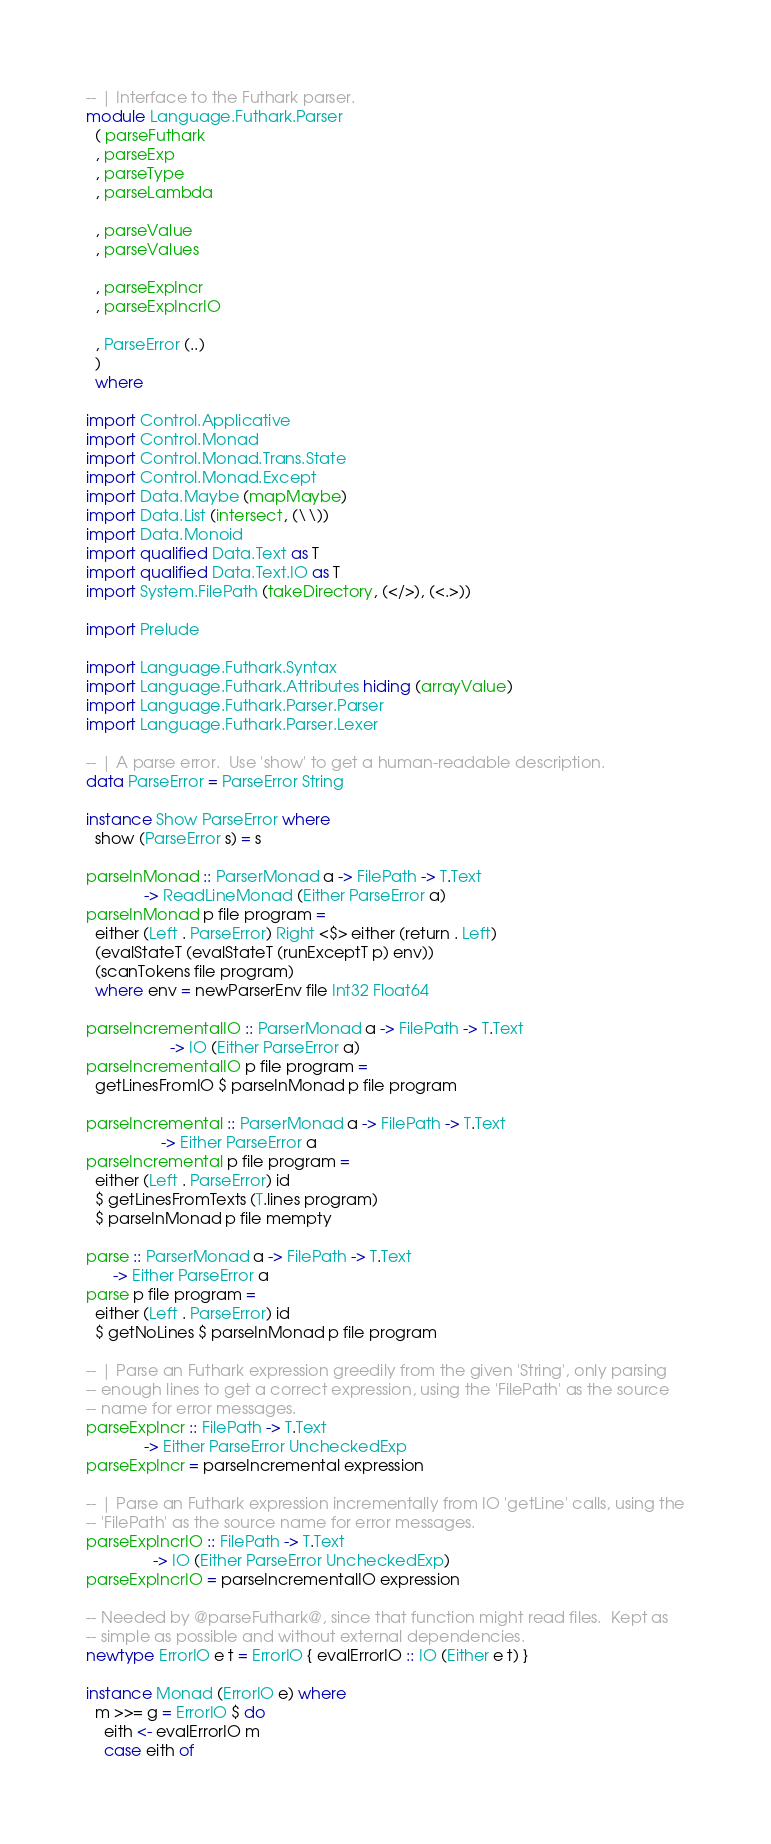Convert code to text. <code><loc_0><loc_0><loc_500><loc_500><_Haskell_>-- | Interface to the Futhark parser.
module Language.Futhark.Parser
  ( parseFuthark
  , parseExp
  , parseType
  , parseLambda

  , parseValue
  , parseValues

  , parseExpIncr
  , parseExpIncrIO

  , ParseError (..)
  )
  where

import Control.Applicative
import Control.Monad
import Control.Monad.Trans.State
import Control.Monad.Except
import Data.Maybe (mapMaybe)
import Data.List (intersect, (\\))
import Data.Monoid
import qualified Data.Text as T
import qualified Data.Text.IO as T
import System.FilePath (takeDirectory, (</>), (<.>))

import Prelude

import Language.Futhark.Syntax
import Language.Futhark.Attributes hiding (arrayValue)
import Language.Futhark.Parser.Parser
import Language.Futhark.Parser.Lexer

-- | A parse error.  Use 'show' to get a human-readable description.
data ParseError = ParseError String

instance Show ParseError where
  show (ParseError s) = s

parseInMonad :: ParserMonad a -> FilePath -> T.Text
             -> ReadLineMonad (Either ParseError a)
parseInMonad p file program =
  either (Left . ParseError) Right <$> either (return . Left)
  (evalStateT (evalStateT (runExceptT p) env))
  (scanTokens file program)
  where env = newParserEnv file Int32 Float64

parseIncrementalIO :: ParserMonad a -> FilePath -> T.Text
                   -> IO (Either ParseError a)
parseIncrementalIO p file program =
  getLinesFromIO $ parseInMonad p file program

parseIncremental :: ParserMonad a -> FilePath -> T.Text
                 -> Either ParseError a
parseIncremental p file program =
  either (Left . ParseError) id
  $ getLinesFromTexts (T.lines program)
  $ parseInMonad p file mempty

parse :: ParserMonad a -> FilePath -> T.Text
      -> Either ParseError a
parse p file program =
  either (Left . ParseError) id
  $ getNoLines $ parseInMonad p file program

-- | Parse an Futhark expression greedily from the given 'String', only parsing
-- enough lines to get a correct expression, using the 'FilePath' as the source
-- name for error messages.
parseExpIncr :: FilePath -> T.Text
             -> Either ParseError UncheckedExp
parseExpIncr = parseIncremental expression

-- | Parse an Futhark expression incrementally from IO 'getLine' calls, using the
-- 'FilePath' as the source name for error messages.
parseExpIncrIO :: FilePath -> T.Text
               -> IO (Either ParseError UncheckedExp)
parseExpIncrIO = parseIncrementalIO expression

-- Needed by @parseFuthark@, since that function might read files.  Kept as
-- simple as possible and without external dependencies.
newtype ErrorIO e t = ErrorIO { evalErrorIO :: IO (Either e t) }

instance Monad (ErrorIO e) where
  m >>= g = ErrorIO $ do
    eith <- evalErrorIO m
    case eith of</code> 